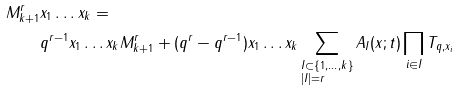Convert formula to latex. <formula><loc_0><loc_0><loc_500><loc_500>M _ { k + 1 } ^ { r } & x _ { 1 } \dots x _ { k } = \\ & q ^ { r - 1 } x _ { 1 } \dots x _ { k } M _ { k + 1 } ^ { r } + ( q ^ { r } - q ^ { r - 1 } ) x _ { 1 } \dots x _ { k } \sum _ { \begin{subarray} { c } I \subset \{ 1 , \dots , k \} \\ | I | = r \end{subarray} } A _ { I } ( x ; t ) \prod _ { i \in I } T _ { q , x _ { i } }</formula> 